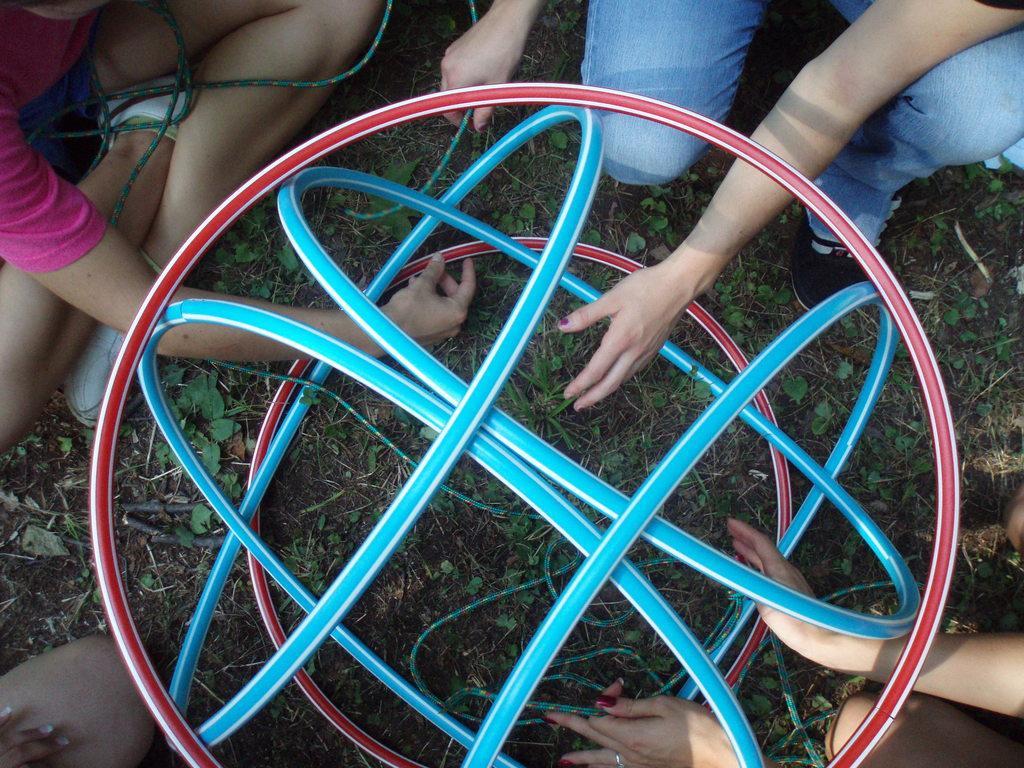Could you give a brief overview of what you see in this image? In this image there are some objects circle in shape at middle of this image. There are four persons in this image. One person is at top right corner of this image is wearing blue color jeans and there is one other person at top left corner of this image is sitting and wearing a white color shoes, and there is one other person at bottom left corner of this image and one more person at bottom right corner of this image. 